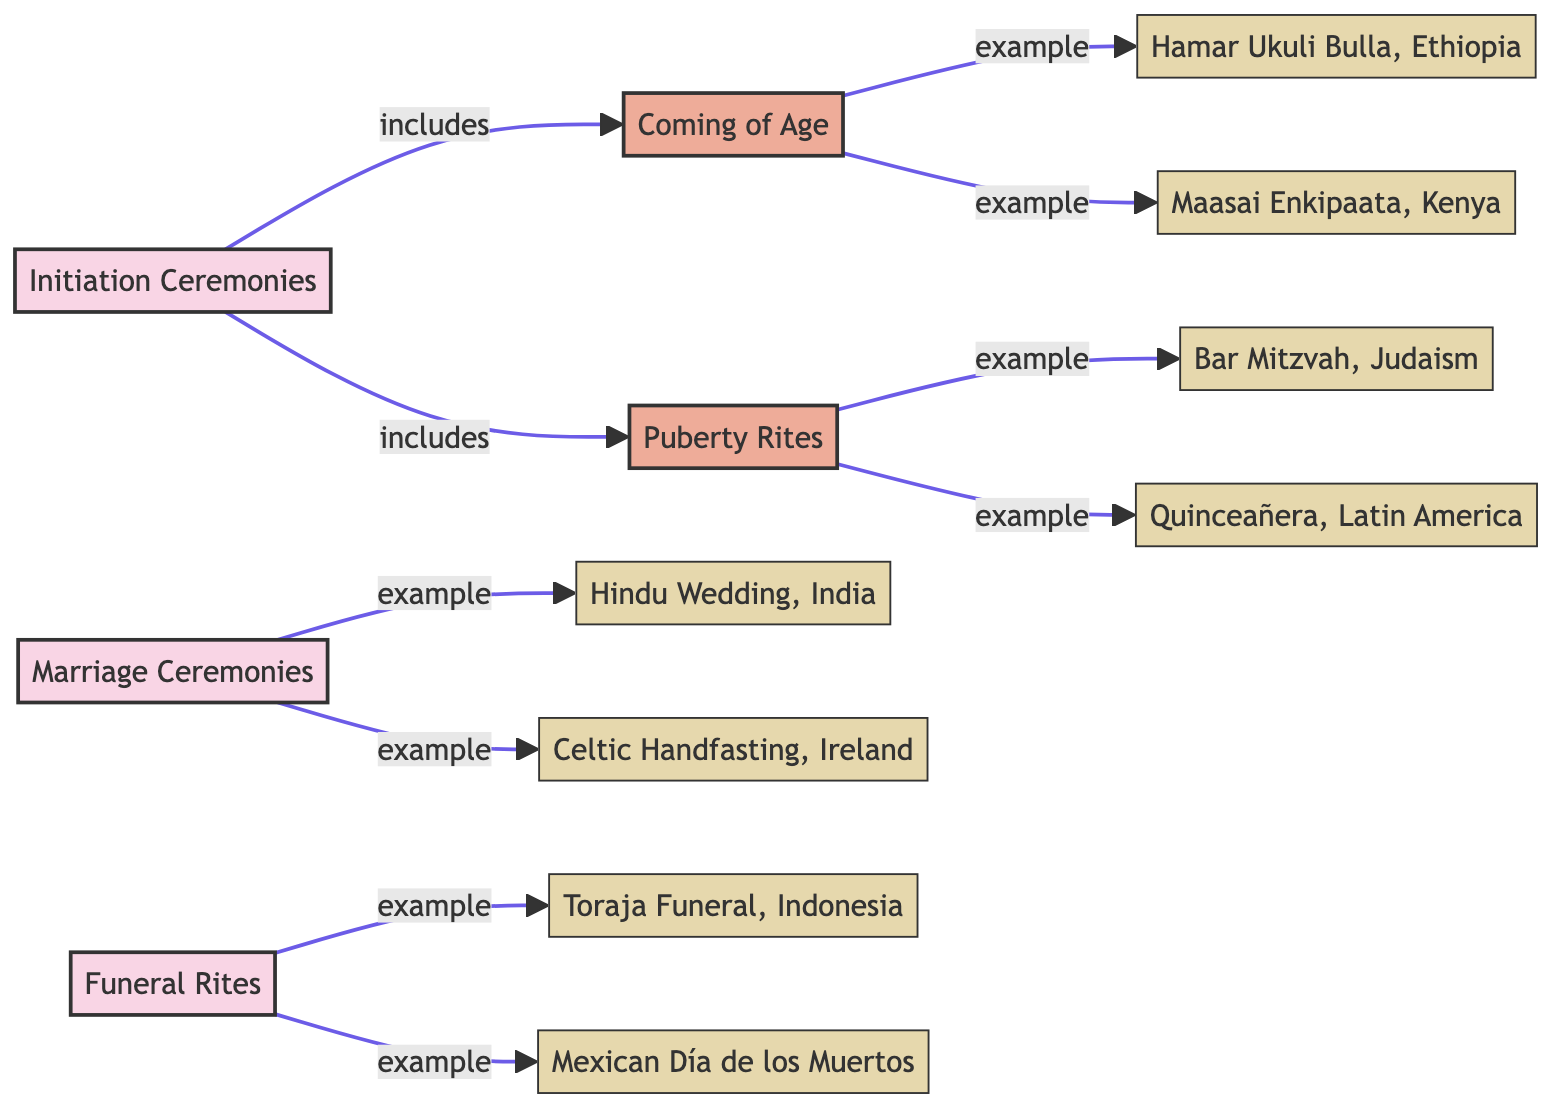What category does the Bar Mitzvah belong to? The Bar Mitzvah is categorized under "Puberty Rites," which is a subcategory of "Initiation Ceremonies." This information is directly indicated by the edges connecting the nodes.
Answer: Puberty Rites How many nodes are present in the diagram? The diagram contains a total of 13 nodes, which include both categories and entities. Counting each node individually provides the answer.
Answer: 13 Which rite of passage is an example of Coming of Age? The Maasai Enkipaata is listed as an example of Coming of Age, according to the connection labeled "example" that links these two nodes.
Answer: Maasai Enkipaata What relationship does Initiation Ceremonies have with Puberty Rites? Initiation Ceremonies includes Puberty Rites, as indicated by the connection labeled "includes" from the Initiation Ceremonies node to the Puberty Rites node.
Answer: includes Which two examples belong to Marriage Ceremonies? The examples that belong to Marriage Ceremonies are the Hindu Wedding and Celtic Handfasting, both of which connect to the Marriage Ceremonies node with the "example" label.
Answer: Hindu Wedding, Celtic Handfasting What type of funeral rite is the Toraja Funeral? The Toraja Funeral is an example of Funeral Rites, as indicated by the "example" connection flowing from the Funeral Rites node to the Toraja Funeral node.
Answer: example Which ceremonial practice is unique to Latin America? The Quinceañera is a ceremonial practice unique to Latin America, categorized under Puberty Rites in the diagram. This is derived from the edges connecting nodes.
Answer: Quinceañera How many subcategories are in the Initial Ceremonies category? There are two subcategories in the Initiation Ceremonies category: Coming of Age and Puberty Rites. This is derived from the connections directly reflected in the diagram.
Answer: 2 What is a common characteristic of all entities in the diagram? All entities in the diagram serve as examples of their respective categories or subcategories, linking them to a specific ceremonial practice. This characteristic is observed through the edges linking entities to their parent categories.
Answer: examples 